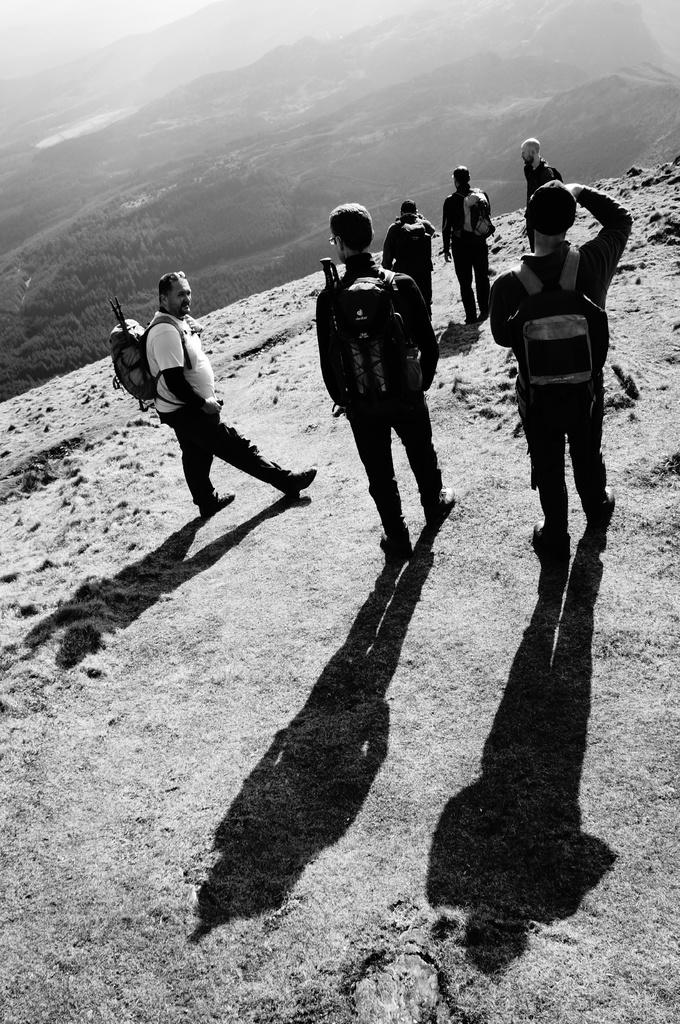What are the people in the image doing? The people in the image are carrying bags. Where are the people standing in the image? The people are standing on the ground. What can be seen in the background of the image? There are mountains and trees visible in the background of the image. What type of creature is pushing the people carrying bags in the image? There is no creature present in the image, and the people are not being pushed. 